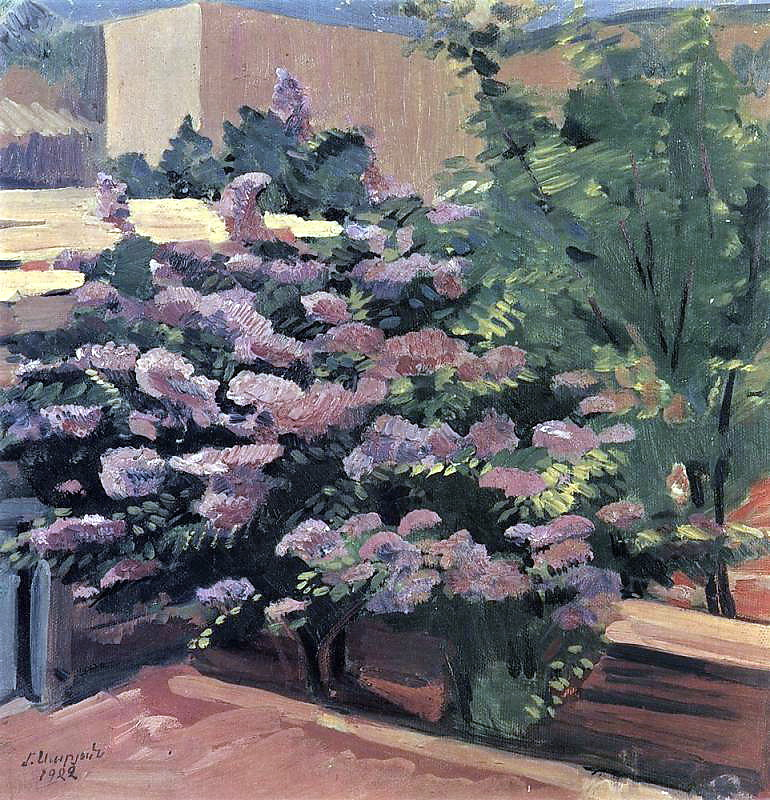Write a detailed description of the given image. The painting is an enchanting piece of art by an impressionist artist signed 'L. Ury' and dated '1924'. It presents a serene garden scene dominated by a flourishing bush adorned with pink and purple flowers. The flowers' vibrant colors contrast beautifully with the lush green and brown tones of the background, hinting at the presence of other plants and trees. A glimpse of blue sky above the foliage introduces a touch of brightness to the scene. The artist employs broad, expressive brush strokes characteristic of the impressionist style, capturing the overall sensory impact and tranquility of the garden. The scene brings forth a sense of calmness, inviting the viewer to explore the tranquility and beauty of a garden in full bloom. 